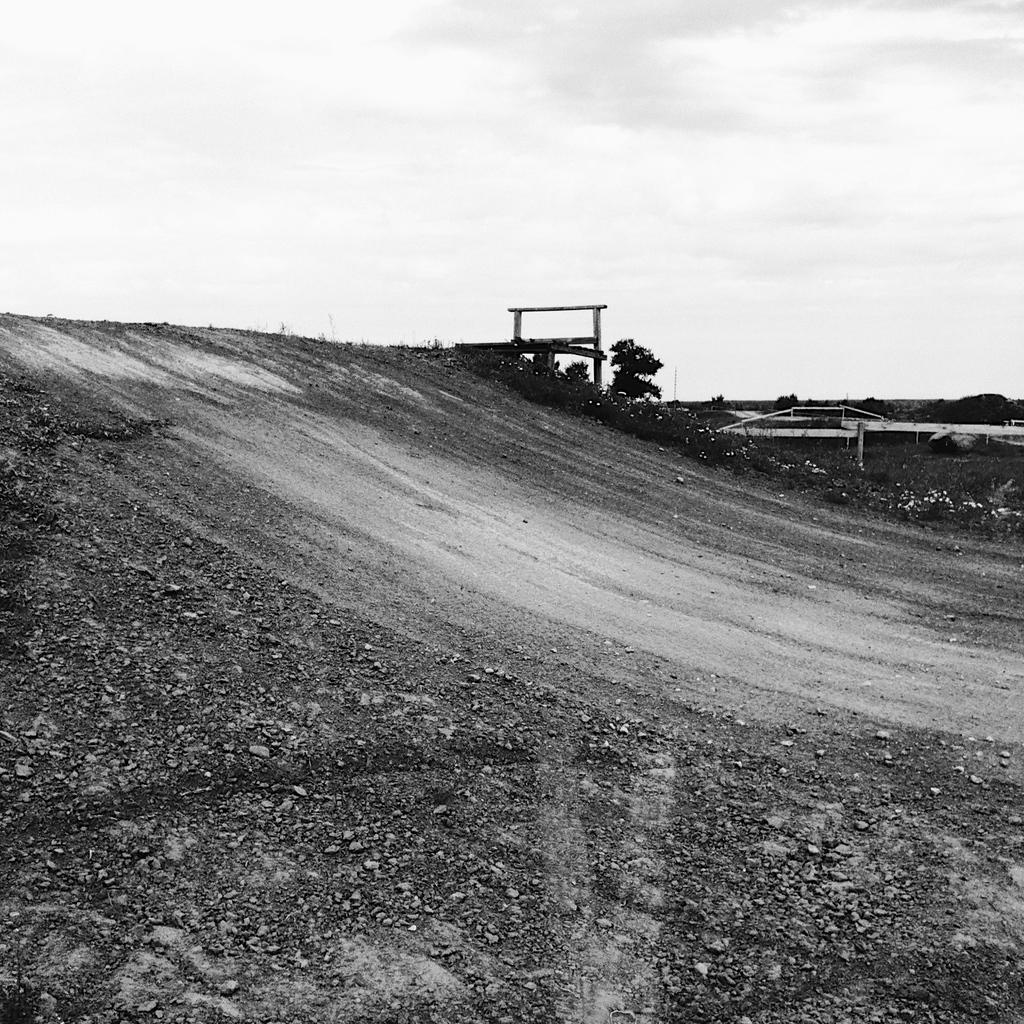What type of surface can be seen in the image? There is ground visible in the image. What type of vegetation is present in the image? There are trees in the image. What else can be seen in the image besides the ground and trees? There are objects in the image. What is visible in the background of the image? The sky is visible in the background of the image. What can be observed in the sky? There are clouds in the sky. What type of cap is being worn by the tree in the image? There are no caps or people present in the image; it features trees and objects on the ground. 